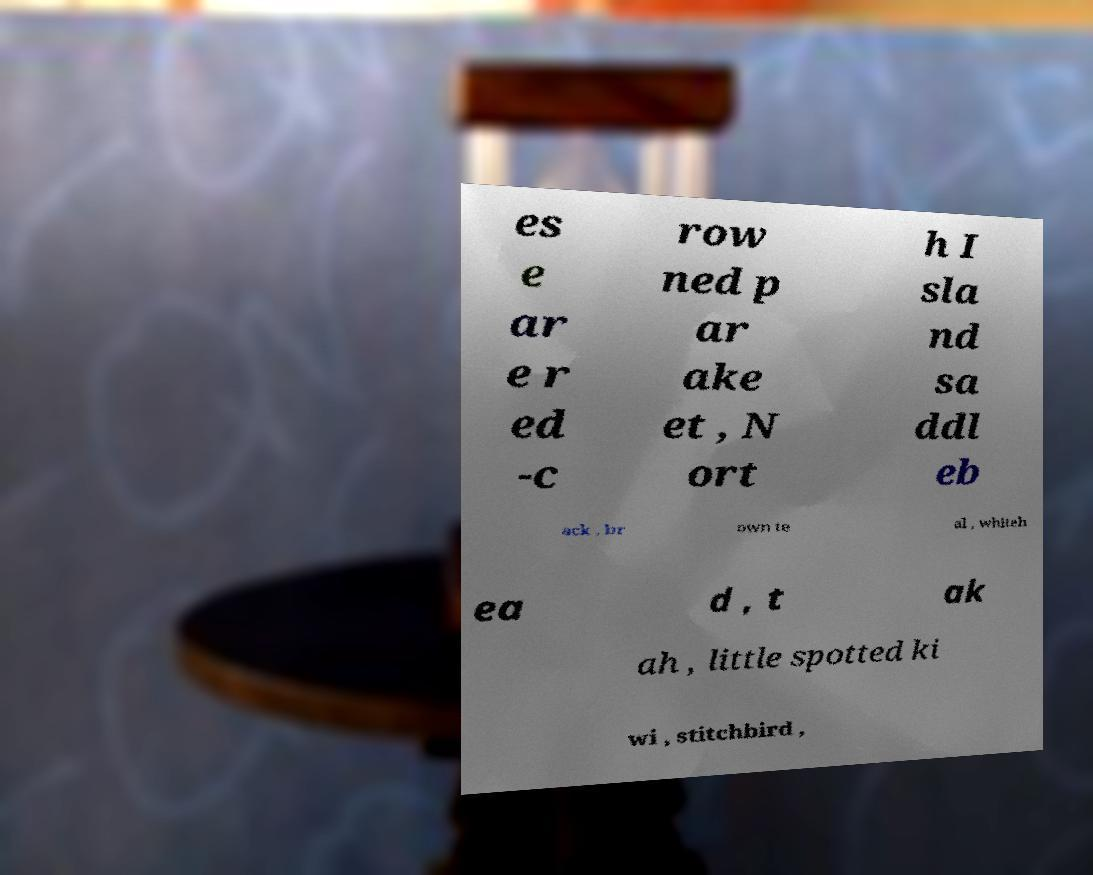Could you assist in decoding the text presented in this image and type it out clearly? es e ar e r ed -c row ned p ar ake et , N ort h I sla nd sa ddl eb ack , br own te al , whiteh ea d , t ak ah , little spotted ki wi , stitchbird , 